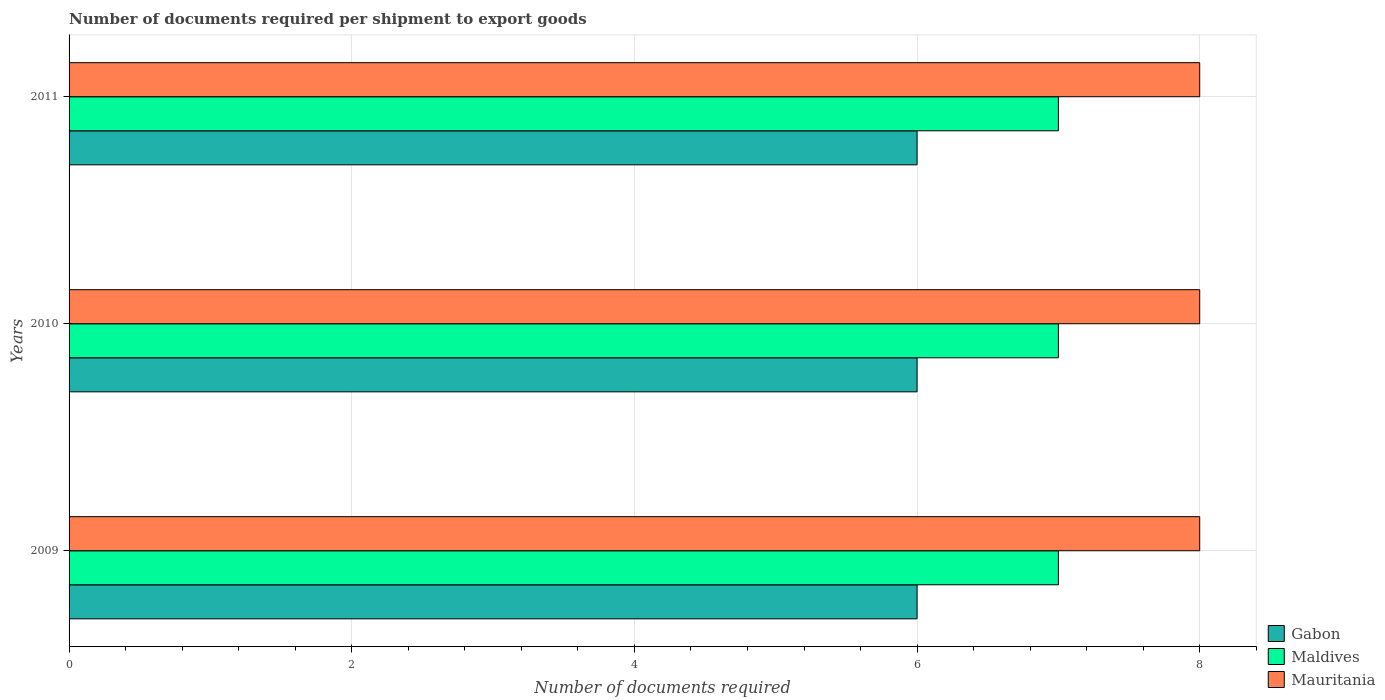Are the number of bars on each tick of the Y-axis equal?
Provide a short and direct response. Yes. In how many cases, is the number of bars for a given year not equal to the number of legend labels?
Give a very brief answer. 0. Across all years, what is the minimum number of documents required per shipment to export goods in Gabon?
Make the answer very short. 6. In which year was the number of documents required per shipment to export goods in Gabon maximum?
Your answer should be compact. 2009. What is the total number of documents required per shipment to export goods in Maldives in the graph?
Keep it short and to the point. 21. What is the difference between the number of documents required per shipment to export goods in Mauritania in 2009 and that in 2010?
Give a very brief answer. 0. What is the difference between the number of documents required per shipment to export goods in Mauritania in 2010 and the number of documents required per shipment to export goods in Maldives in 2011?
Offer a terse response. 1. What is the average number of documents required per shipment to export goods in Mauritania per year?
Offer a very short reply. 8. In the year 2011, what is the difference between the number of documents required per shipment to export goods in Gabon and number of documents required per shipment to export goods in Mauritania?
Make the answer very short. -2. Is the number of documents required per shipment to export goods in Mauritania in 2009 less than that in 2010?
Offer a very short reply. No. Is the difference between the number of documents required per shipment to export goods in Gabon in 2009 and 2011 greater than the difference between the number of documents required per shipment to export goods in Mauritania in 2009 and 2011?
Provide a succinct answer. No. What is the difference between the highest and the second highest number of documents required per shipment to export goods in Mauritania?
Give a very brief answer. 0. What is the difference between the highest and the lowest number of documents required per shipment to export goods in Gabon?
Offer a terse response. 0. In how many years, is the number of documents required per shipment to export goods in Gabon greater than the average number of documents required per shipment to export goods in Gabon taken over all years?
Give a very brief answer. 0. Is the sum of the number of documents required per shipment to export goods in Maldives in 2009 and 2010 greater than the maximum number of documents required per shipment to export goods in Mauritania across all years?
Keep it short and to the point. Yes. What does the 3rd bar from the top in 2011 represents?
Your answer should be compact. Gabon. What does the 2nd bar from the bottom in 2010 represents?
Provide a succinct answer. Maldives. How many bars are there?
Make the answer very short. 9. How many years are there in the graph?
Your response must be concise. 3. What is the difference between two consecutive major ticks on the X-axis?
Offer a terse response. 2. Does the graph contain grids?
Offer a terse response. Yes. How many legend labels are there?
Ensure brevity in your answer.  3. How are the legend labels stacked?
Provide a short and direct response. Vertical. What is the title of the graph?
Your answer should be very brief. Number of documents required per shipment to export goods. Does "East Asia (developing only)" appear as one of the legend labels in the graph?
Provide a succinct answer. No. What is the label or title of the X-axis?
Provide a short and direct response. Number of documents required. What is the label or title of the Y-axis?
Your response must be concise. Years. What is the Number of documents required of Gabon in 2009?
Give a very brief answer. 6. What is the Number of documents required in Maldives in 2009?
Your answer should be very brief. 7. What is the Number of documents required in Mauritania in 2009?
Keep it short and to the point. 8. What is the Number of documents required in Mauritania in 2010?
Make the answer very short. 8. What is the Number of documents required in Mauritania in 2011?
Give a very brief answer. 8. Across all years, what is the maximum Number of documents required of Gabon?
Your answer should be very brief. 6. Across all years, what is the minimum Number of documents required of Gabon?
Provide a short and direct response. 6. Across all years, what is the minimum Number of documents required in Maldives?
Provide a succinct answer. 7. What is the total Number of documents required in Gabon in the graph?
Make the answer very short. 18. What is the total Number of documents required of Maldives in the graph?
Your answer should be very brief. 21. What is the total Number of documents required of Mauritania in the graph?
Provide a short and direct response. 24. What is the difference between the Number of documents required of Gabon in 2009 and that in 2010?
Provide a short and direct response. 0. What is the difference between the Number of documents required of Maldives in 2009 and that in 2010?
Keep it short and to the point. 0. What is the difference between the Number of documents required in Gabon in 2009 and that in 2011?
Your answer should be compact. 0. What is the difference between the Number of documents required in Maldives in 2009 and that in 2011?
Your answer should be very brief. 0. What is the difference between the Number of documents required in Mauritania in 2009 and that in 2011?
Provide a short and direct response. 0. What is the difference between the Number of documents required of Gabon in 2010 and that in 2011?
Give a very brief answer. 0. What is the difference between the Number of documents required in Mauritania in 2010 and that in 2011?
Offer a terse response. 0. What is the difference between the Number of documents required of Gabon in 2009 and the Number of documents required of Maldives in 2010?
Provide a short and direct response. -1. What is the difference between the Number of documents required in Maldives in 2009 and the Number of documents required in Mauritania in 2010?
Provide a succinct answer. -1. What is the difference between the Number of documents required of Gabon in 2009 and the Number of documents required of Mauritania in 2011?
Your answer should be very brief. -2. What is the difference between the Number of documents required of Maldives in 2009 and the Number of documents required of Mauritania in 2011?
Keep it short and to the point. -1. What is the difference between the Number of documents required in Gabon in 2010 and the Number of documents required in Mauritania in 2011?
Your response must be concise. -2. What is the difference between the Number of documents required of Maldives in 2010 and the Number of documents required of Mauritania in 2011?
Your answer should be very brief. -1. What is the average Number of documents required of Gabon per year?
Your answer should be compact. 6. In the year 2010, what is the difference between the Number of documents required of Gabon and Number of documents required of Maldives?
Make the answer very short. -1. In the year 2010, what is the difference between the Number of documents required of Gabon and Number of documents required of Mauritania?
Your response must be concise. -2. In the year 2010, what is the difference between the Number of documents required in Maldives and Number of documents required in Mauritania?
Your answer should be very brief. -1. In the year 2011, what is the difference between the Number of documents required in Gabon and Number of documents required in Mauritania?
Keep it short and to the point. -2. In the year 2011, what is the difference between the Number of documents required in Maldives and Number of documents required in Mauritania?
Your response must be concise. -1. What is the ratio of the Number of documents required of Maldives in 2009 to that in 2010?
Your answer should be compact. 1. What is the ratio of the Number of documents required in Maldives in 2009 to that in 2011?
Give a very brief answer. 1. What is the ratio of the Number of documents required in Gabon in 2010 to that in 2011?
Provide a short and direct response. 1. What is the ratio of the Number of documents required of Maldives in 2010 to that in 2011?
Give a very brief answer. 1. What is the difference between the highest and the second highest Number of documents required of Gabon?
Provide a succinct answer. 0. What is the difference between the highest and the lowest Number of documents required of Maldives?
Offer a terse response. 0. 